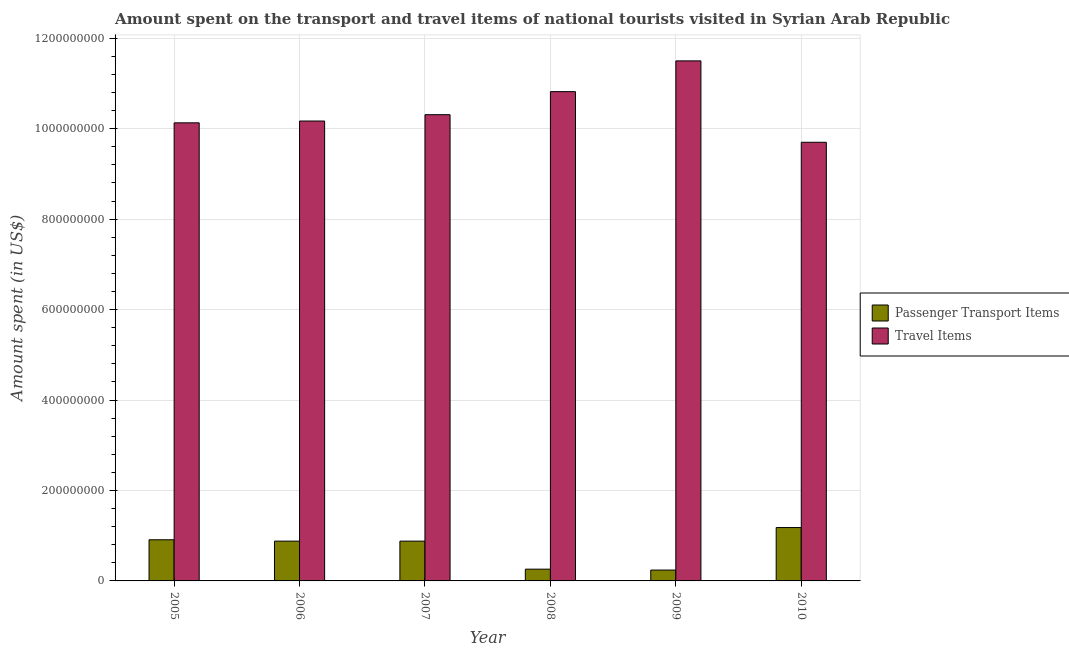How many bars are there on the 3rd tick from the left?
Offer a terse response. 2. What is the label of the 5th group of bars from the left?
Ensure brevity in your answer.  2009. What is the amount spent in travel items in 2010?
Make the answer very short. 9.70e+08. Across all years, what is the maximum amount spent in travel items?
Ensure brevity in your answer.  1.15e+09. Across all years, what is the minimum amount spent on passenger transport items?
Provide a succinct answer. 2.40e+07. What is the total amount spent in travel items in the graph?
Ensure brevity in your answer.  6.26e+09. What is the difference between the amount spent on passenger transport items in 2008 and that in 2010?
Your response must be concise. -9.20e+07. What is the difference between the amount spent on passenger transport items in 2010 and the amount spent in travel items in 2007?
Offer a terse response. 3.00e+07. What is the average amount spent in travel items per year?
Your response must be concise. 1.04e+09. What is the ratio of the amount spent in travel items in 2005 to that in 2009?
Ensure brevity in your answer.  0.88. Is the difference between the amount spent on passenger transport items in 2007 and 2009 greater than the difference between the amount spent in travel items in 2007 and 2009?
Your answer should be very brief. No. What is the difference between the highest and the second highest amount spent in travel items?
Offer a very short reply. 6.80e+07. What is the difference between the highest and the lowest amount spent on passenger transport items?
Your answer should be very brief. 9.40e+07. In how many years, is the amount spent on passenger transport items greater than the average amount spent on passenger transport items taken over all years?
Offer a terse response. 4. What does the 2nd bar from the left in 2006 represents?
Keep it short and to the point. Travel Items. What does the 2nd bar from the right in 2006 represents?
Ensure brevity in your answer.  Passenger Transport Items. How many bars are there?
Give a very brief answer. 12. Does the graph contain grids?
Provide a succinct answer. Yes. Where does the legend appear in the graph?
Offer a terse response. Center right. How many legend labels are there?
Keep it short and to the point. 2. What is the title of the graph?
Offer a very short reply. Amount spent on the transport and travel items of national tourists visited in Syrian Arab Republic. What is the label or title of the X-axis?
Your answer should be compact. Year. What is the label or title of the Y-axis?
Keep it short and to the point. Amount spent (in US$). What is the Amount spent (in US$) of Passenger Transport Items in 2005?
Your answer should be compact. 9.10e+07. What is the Amount spent (in US$) in Travel Items in 2005?
Provide a short and direct response. 1.01e+09. What is the Amount spent (in US$) in Passenger Transport Items in 2006?
Give a very brief answer. 8.80e+07. What is the Amount spent (in US$) in Travel Items in 2006?
Keep it short and to the point. 1.02e+09. What is the Amount spent (in US$) of Passenger Transport Items in 2007?
Provide a short and direct response. 8.80e+07. What is the Amount spent (in US$) in Travel Items in 2007?
Keep it short and to the point. 1.03e+09. What is the Amount spent (in US$) of Passenger Transport Items in 2008?
Provide a succinct answer. 2.60e+07. What is the Amount spent (in US$) in Travel Items in 2008?
Give a very brief answer. 1.08e+09. What is the Amount spent (in US$) of Passenger Transport Items in 2009?
Offer a terse response. 2.40e+07. What is the Amount spent (in US$) in Travel Items in 2009?
Offer a very short reply. 1.15e+09. What is the Amount spent (in US$) of Passenger Transport Items in 2010?
Provide a succinct answer. 1.18e+08. What is the Amount spent (in US$) in Travel Items in 2010?
Offer a terse response. 9.70e+08. Across all years, what is the maximum Amount spent (in US$) in Passenger Transport Items?
Provide a succinct answer. 1.18e+08. Across all years, what is the maximum Amount spent (in US$) in Travel Items?
Your answer should be very brief. 1.15e+09. Across all years, what is the minimum Amount spent (in US$) of Passenger Transport Items?
Give a very brief answer. 2.40e+07. Across all years, what is the minimum Amount spent (in US$) of Travel Items?
Provide a succinct answer. 9.70e+08. What is the total Amount spent (in US$) in Passenger Transport Items in the graph?
Offer a very short reply. 4.35e+08. What is the total Amount spent (in US$) of Travel Items in the graph?
Your answer should be very brief. 6.26e+09. What is the difference between the Amount spent (in US$) in Travel Items in 2005 and that in 2006?
Ensure brevity in your answer.  -4.00e+06. What is the difference between the Amount spent (in US$) of Passenger Transport Items in 2005 and that in 2007?
Your response must be concise. 3.00e+06. What is the difference between the Amount spent (in US$) in Travel Items in 2005 and that in 2007?
Ensure brevity in your answer.  -1.80e+07. What is the difference between the Amount spent (in US$) in Passenger Transport Items in 2005 and that in 2008?
Your response must be concise. 6.50e+07. What is the difference between the Amount spent (in US$) of Travel Items in 2005 and that in 2008?
Ensure brevity in your answer.  -6.90e+07. What is the difference between the Amount spent (in US$) in Passenger Transport Items in 2005 and that in 2009?
Your response must be concise. 6.70e+07. What is the difference between the Amount spent (in US$) of Travel Items in 2005 and that in 2009?
Offer a very short reply. -1.37e+08. What is the difference between the Amount spent (in US$) of Passenger Transport Items in 2005 and that in 2010?
Offer a very short reply. -2.70e+07. What is the difference between the Amount spent (in US$) in Travel Items in 2005 and that in 2010?
Give a very brief answer. 4.30e+07. What is the difference between the Amount spent (in US$) of Passenger Transport Items in 2006 and that in 2007?
Provide a succinct answer. 0. What is the difference between the Amount spent (in US$) in Travel Items in 2006 and that in 2007?
Make the answer very short. -1.40e+07. What is the difference between the Amount spent (in US$) in Passenger Transport Items in 2006 and that in 2008?
Give a very brief answer. 6.20e+07. What is the difference between the Amount spent (in US$) of Travel Items in 2006 and that in 2008?
Give a very brief answer. -6.50e+07. What is the difference between the Amount spent (in US$) of Passenger Transport Items in 2006 and that in 2009?
Give a very brief answer. 6.40e+07. What is the difference between the Amount spent (in US$) in Travel Items in 2006 and that in 2009?
Your answer should be very brief. -1.33e+08. What is the difference between the Amount spent (in US$) of Passenger Transport Items in 2006 and that in 2010?
Give a very brief answer. -3.00e+07. What is the difference between the Amount spent (in US$) of Travel Items in 2006 and that in 2010?
Offer a terse response. 4.70e+07. What is the difference between the Amount spent (in US$) of Passenger Transport Items in 2007 and that in 2008?
Offer a very short reply. 6.20e+07. What is the difference between the Amount spent (in US$) in Travel Items in 2007 and that in 2008?
Make the answer very short. -5.10e+07. What is the difference between the Amount spent (in US$) in Passenger Transport Items in 2007 and that in 2009?
Make the answer very short. 6.40e+07. What is the difference between the Amount spent (in US$) of Travel Items in 2007 and that in 2009?
Your answer should be very brief. -1.19e+08. What is the difference between the Amount spent (in US$) of Passenger Transport Items in 2007 and that in 2010?
Keep it short and to the point. -3.00e+07. What is the difference between the Amount spent (in US$) in Travel Items in 2007 and that in 2010?
Your response must be concise. 6.10e+07. What is the difference between the Amount spent (in US$) of Passenger Transport Items in 2008 and that in 2009?
Provide a short and direct response. 2.00e+06. What is the difference between the Amount spent (in US$) of Travel Items in 2008 and that in 2009?
Your answer should be very brief. -6.80e+07. What is the difference between the Amount spent (in US$) in Passenger Transport Items in 2008 and that in 2010?
Provide a succinct answer. -9.20e+07. What is the difference between the Amount spent (in US$) of Travel Items in 2008 and that in 2010?
Offer a very short reply. 1.12e+08. What is the difference between the Amount spent (in US$) of Passenger Transport Items in 2009 and that in 2010?
Your answer should be compact. -9.40e+07. What is the difference between the Amount spent (in US$) of Travel Items in 2009 and that in 2010?
Ensure brevity in your answer.  1.80e+08. What is the difference between the Amount spent (in US$) in Passenger Transport Items in 2005 and the Amount spent (in US$) in Travel Items in 2006?
Keep it short and to the point. -9.26e+08. What is the difference between the Amount spent (in US$) in Passenger Transport Items in 2005 and the Amount spent (in US$) in Travel Items in 2007?
Provide a succinct answer. -9.40e+08. What is the difference between the Amount spent (in US$) in Passenger Transport Items in 2005 and the Amount spent (in US$) in Travel Items in 2008?
Your response must be concise. -9.91e+08. What is the difference between the Amount spent (in US$) in Passenger Transport Items in 2005 and the Amount spent (in US$) in Travel Items in 2009?
Your answer should be very brief. -1.06e+09. What is the difference between the Amount spent (in US$) of Passenger Transport Items in 2005 and the Amount spent (in US$) of Travel Items in 2010?
Give a very brief answer. -8.79e+08. What is the difference between the Amount spent (in US$) of Passenger Transport Items in 2006 and the Amount spent (in US$) of Travel Items in 2007?
Offer a terse response. -9.43e+08. What is the difference between the Amount spent (in US$) in Passenger Transport Items in 2006 and the Amount spent (in US$) in Travel Items in 2008?
Keep it short and to the point. -9.94e+08. What is the difference between the Amount spent (in US$) in Passenger Transport Items in 2006 and the Amount spent (in US$) in Travel Items in 2009?
Your answer should be very brief. -1.06e+09. What is the difference between the Amount spent (in US$) in Passenger Transport Items in 2006 and the Amount spent (in US$) in Travel Items in 2010?
Offer a terse response. -8.82e+08. What is the difference between the Amount spent (in US$) of Passenger Transport Items in 2007 and the Amount spent (in US$) of Travel Items in 2008?
Your answer should be very brief. -9.94e+08. What is the difference between the Amount spent (in US$) of Passenger Transport Items in 2007 and the Amount spent (in US$) of Travel Items in 2009?
Provide a succinct answer. -1.06e+09. What is the difference between the Amount spent (in US$) in Passenger Transport Items in 2007 and the Amount spent (in US$) in Travel Items in 2010?
Provide a succinct answer. -8.82e+08. What is the difference between the Amount spent (in US$) of Passenger Transport Items in 2008 and the Amount spent (in US$) of Travel Items in 2009?
Your answer should be compact. -1.12e+09. What is the difference between the Amount spent (in US$) of Passenger Transport Items in 2008 and the Amount spent (in US$) of Travel Items in 2010?
Your answer should be compact. -9.44e+08. What is the difference between the Amount spent (in US$) in Passenger Transport Items in 2009 and the Amount spent (in US$) in Travel Items in 2010?
Give a very brief answer. -9.46e+08. What is the average Amount spent (in US$) of Passenger Transport Items per year?
Keep it short and to the point. 7.25e+07. What is the average Amount spent (in US$) in Travel Items per year?
Give a very brief answer. 1.04e+09. In the year 2005, what is the difference between the Amount spent (in US$) of Passenger Transport Items and Amount spent (in US$) of Travel Items?
Offer a very short reply. -9.22e+08. In the year 2006, what is the difference between the Amount spent (in US$) in Passenger Transport Items and Amount spent (in US$) in Travel Items?
Provide a short and direct response. -9.29e+08. In the year 2007, what is the difference between the Amount spent (in US$) of Passenger Transport Items and Amount spent (in US$) of Travel Items?
Ensure brevity in your answer.  -9.43e+08. In the year 2008, what is the difference between the Amount spent (in US$) of Passenger Transport Items and Amount spent (in US$) of Travel Items?
Offer a very short reply. -1.06e+09. In the year 2009, what is the difference between the Amount spent (in US$) in Passenger Transport Items and Amount spent (in US$) in Travel Items?
Give a very brief answer. -1.13e+09. In the year 2010, what is the difference between the Amount spent (in US$) of Passenger Transport Items and Amount spent (in US$) of Travel Items?
Offer a terse response. -8.52e+08. What is the ratio of the Amount spent (in US$) in Passenger Transport Items in 2005 to that in 2006?
Offer a very short reply. 1.03. What is the ratio of the Amount spent (in US$) of Travel Items in 2005 to that in 2006?
Keep it short and to the point. 1. What is the ratio of the Amount spent (in US$) in Passenger Transport Items in 2005 to that in 2007?
Offer a terse response. 1.03. What is the ratio of the Amount spent (in US$) in Travel Items in 2005 to that in 2007?
Provide a short and direct response. 0.98. What is the ratio of the Amount spent (in US$) in Travel Items in 2005 to that in 2008?
Ensure brevity in your answer.  0.94. What is the ratio of the Amount spent (in US$) in Passenger Transport Items in 2005 to that in 2009?
Your answer should be compact. 3.79. What is the ratio of the Amount spent (in US$) in Travel Items in 2005 to that in 2009?
Your answer should be compact. 0.88. What is the ratio of the Amount spent (in US$) of Passenger Transport Items in 2005 to that in 2010?
Make the answer very short. 0.77. What is the ratio of the Amount spent (in US$) in Travel Items in 2005 to that in 2010?
Your response must be concise. 1.04. What is the ratio of the Amount spent (in US$) of Travel Items in 2006 to that in 2007?
Give a very brief answer. 0.99. What is the ratio of the Amount spent (in US$) of Passenger Transport Items in 2006 to that in 2008?
Provide a short and direct response. 3.38. What is the ratio of the Amount spent (in US$) of Travel Items in 2006 to that in 2008?
Give a very brief answer. 0.94. What is the ratio of the Amount spent (in US$) of Passenger Transport Items in 2006 to that in 2009?
Provide a short and direct response. 3.67. What is the ratio of the Amount spent (in US$) in Travel Items in 2006 to that in 2009?
Your response must be concise. 0.88. What is the ratio of the Amount spent (in US$) of Passenger Transport Items in 2006 to that in 2010?
Provide a short and direct response. 0.75. What is the ratio of the Amount spent (in US$) of Travel Items in 2006 to that in 2010?
Your response must be concise. 1.05. What is the ratio of the Amount spent (in US$) in Passenger Transport Items in 2007 to that in 2008?
Offer a very short reply. 3.38. What is the ratio of the Amount spent (in US$) in Travel Items in 2007 to that in 2008?
Your answer should be very brief. 0.95. What is the ratio of the Amount spent (in US$) of Passenger Transport Items in 2007 to that in 2009?
Your response must be concise. 3.67. What is the ratio of the Amount spent (in US$) of Travel Items in 2007 to that in 2009?
Your answer should be compact. 0.9. What is the ratio of the Amount spent (in US$) in Passenger Transport Items in 2007 to that in 2010?
Keep it short and to the point. 0.75. What is the ratio of the Amount spent (in US$) in Travel Items in 2007 to that in 2010?
Keep it short and to the point. 1.06. What is the ratio of the Amount spent (in US$) in Travel Items in 2008 to that in 2009?
Keep it short and to the point. 0.94. What is the ratio of the Amount spent (in US$) of Passenger Transport Items in 2008 to that in 2010?
Provide a short and direct response. 0.22. What is the ratio of the Amount spent (in US$) in Travel Items in 2008 to that in 2010?
Your response must be concise. 1.12. What is the ratio of the Amount spent (in US$) in Passenger Transport Items in 2009 to that in 2010?
Your response must be concise. 0.2. What is the ratio of the Amount spent (in US$) of Travel Items in 2009 to that in 2010?
Provide a succinct answer. 1.19. What is the difference between the highest and the second highest Amount spent (in US$) in Passenger Transport Items?
Your answer should be compact. 2.70e+07. What is the difference between the highest and the second highest Amount spent (in US$) in Travel Items?
Provide a succinct answer. 6.80e+07. What is the difference between the highest and the lowest Amount spent (in US$) in Passenger Transport Items?
Provide a short and direct response. 9.40e+07. What is the difference between the highest and the lowest Amount spent (in US$) of Travel Items?
Offer a very short reply. 1.80e+08. 